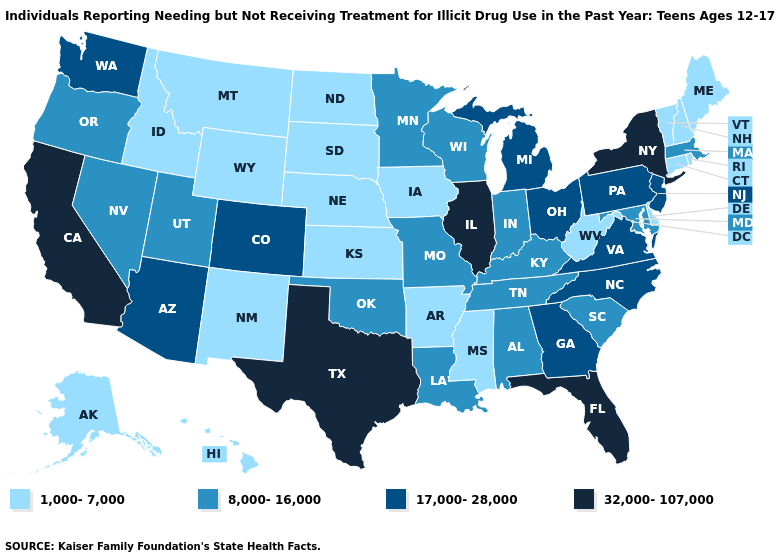Name the states that have a value in the range 8,000-16,000?
Keep it brief. Alabama, Indiana, Kentucky, Louisiana, Maryland, Massachusetts, Minnesota, Missouri, Nevada, Oklahoma, Oregon, South Carolina, Tennessee, Utah, Wisconsin. Does the first symbol in the legend represent the smallest category?
Give a very brief answer. Yes. Among the states that border Georgia , which have the lowest value?
Answer briefly. Alabama, South Carolina, Tennessee. Among the states that border Oregon , does Idaho have the lowest value?
Short answer required. Yes. Does the map have missing data?
Keep it brief. No. Name the states that have a value in the range 8,000-16,000?
Short answer required. Alabama, Indiana, Kentucky, Louisiana, Maryland, Massachusetts, Minnesota, Missouri, Nevada, Oklahoma, Oregon, South Carolina, Tennessee, Utah, Wisconsin. Name the states that have a value in the range 8,000-16,000?
Short answer required. Alabama, Indiana, Kentucky, Louisiana, Maryland, Massachusetts, Minnesota, Missouri, Nevada, Oklahoma, Oregon, South Carolina, Tennessee, Utah, Wisconsin. Among the states that border Ohio , which have the highest value?
Concise answer only. Michigan, Pennsylvania. What is the value of Kentucky?
Give a very brief answer. 8,000-16,000. What is the value of Kentucky?
Concise answer only. 8,000-16,000. What is the value of Tennessee?
Keep it brief. 8,000-16,000. Name the states that have a value in the range 17,000-28,000?
Write a very short answer. Arizona, Colorado, Georgia, Michigan, New Jersey, North Carolina, Ohio, Pennsylvania, Virginia, Washington. Name the states that have a value in the range 1,000-7,000?
Concise answer only. Alaska, Arkansas, Connecticut, Delaware, Hawaii, Idaho, Iowa, Kansas, Maine, Mississippi, Montana, Nebraska, New Hampshire, New Mexico, North Dakota, Rhode Island, South Dakota, Vermont, West Virginia, Wyoming. Which states have the lowest value in the West?
Keep it brief. Alaska, Hawaii, Idaho, Montana, New Mexico, Wyoming. 